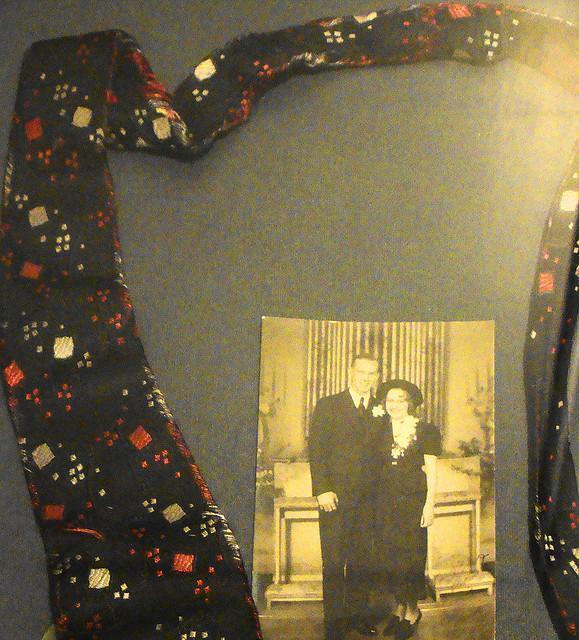How many people are there?
Give a very brief answer. 2. How many giraffes are there?
Give a very brief answer. 0. 